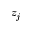<formula> <loc_0><loc_0><loc_500><loc_500>z _ { j }</formula> 